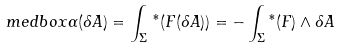Convert formula to latex. <formula><loc_0><loc_0><loc_500><loc_500>\ m e d b o x { \alpha ( \delta { A } ) = \int _ { \Sigma } { \, ^ { * } ( F ( \delta { A } ) ) } = - \int _ { \Sigma } { ^ { * } ( F ) \wedge \delta A } }</formula> 